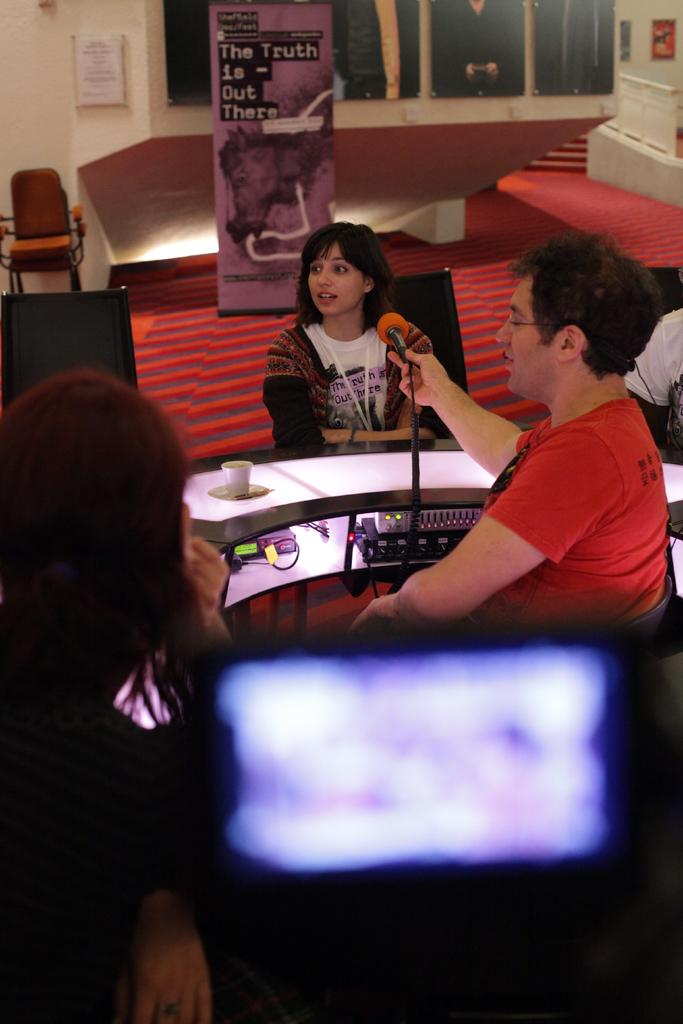What is the man doing in the image? The man is sitting on the right side of the image and holding a microphone. Who else is present in the image? There is a woman sitting in the image. What is the woman's position in the image? The woman is sitting on a chair. What can be seen in the image that provides illumination? There is a light in the image. What type of authority does the man have in the image? There is no indication of the man's authority in the image; he is simply holding a microphone. Can you tell me how many kettles are visible in the image? There are no kettles present in the image. 